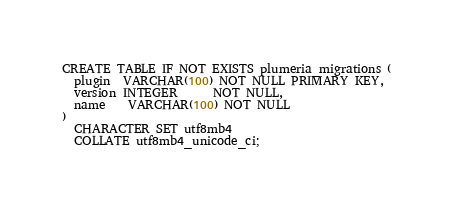Convert code to text. <code><loc_0><loc_0><loc_500><loc_500><_SQL_>CREATE TABLE IF NOT EXISTS plumeria_migrations (
  plugin  VARCHAR(100) NOT NULL PRIMARY KEY,
  version INTEGER      NOT NULL,
  name    VARCHAR(100) NOT NULL
)
  CHARACTER SET utf8mb4
  COLLATE utf8mb4_unicode_ci;
</code> 